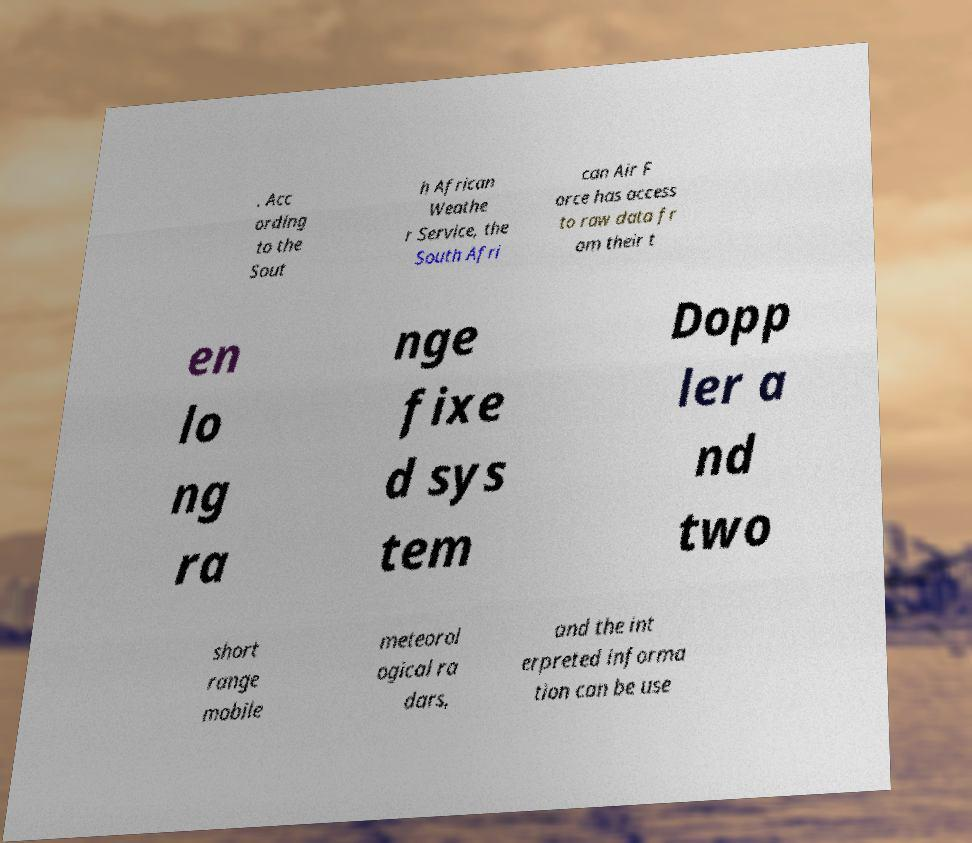I need the written content from this picture converted into text. Can you do that? . Acc ording to the Sout h African Weathe r Service, the South Afri can Air F orce has access to raw data fr om their t en lo ng ra nge fixe d sys tem Dopp ler a nd two short range mobile meteorol ogical ra dars, and the int erpreted informa tion can be use 